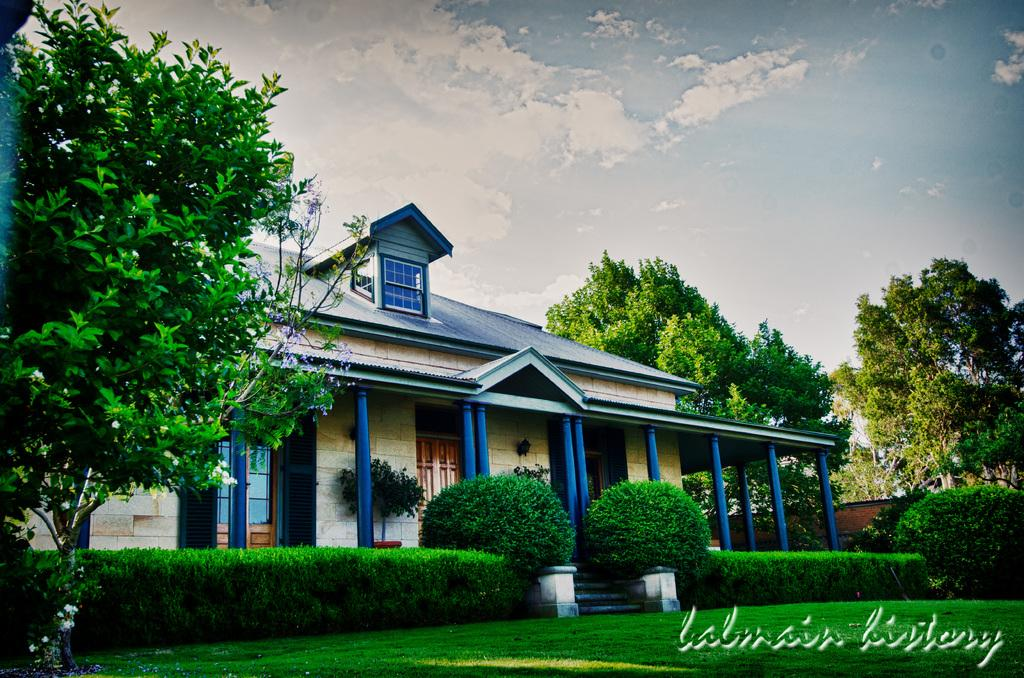What type of structure is visible in the image? There is a house in the image. What natural elements can be seen in the image? There are many trees and plants in the image. What is the condition of the lawn in the image? There is a grassy lawn in the image. How would you describe the sky in the image? The sky is blue and slightly cloudy in the image. What type of jeans is the house wearing in the image? The house is not wearing jeans, as it is a structure and not a living being. 